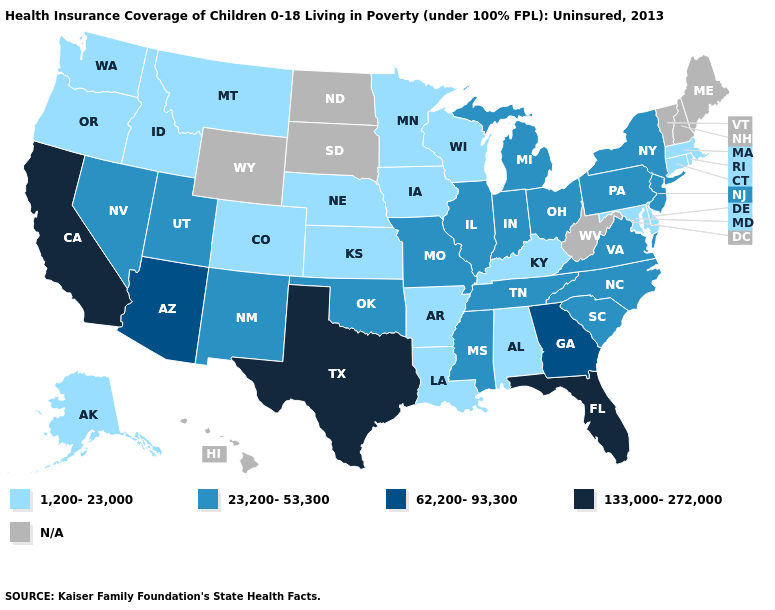How many symbols are there in the legend?
Quick response, please. 5. What is the value of Maryland?
Keep it brief. 1,200-23,000. What is the value of Georgia?
Quick response, please. 62,200-93,300. What is the value of South Dakota?
Keep it brief. N/A. Name the states that have a value in the range 1,200-23,000?
Write a very short answer. Alabama, Alaska, Arkansas, Colorado, Connecticut, Delaware, Idaho, Iowa, Kansas, Kentucky, Louisiana, Maryland, Massachusetts, Minnesota, Montana, Nebraska, Oregon, Rhode Island, Washington, Wisconsin. Name the states that have a value in the range 23,200-53,300?
Be succinct. Illinois, Indiana, Michigan, Mississippi, Missouri, Nevada, New Jersey, New Mexico, New York, North Carolina, Ohio, Oklahoma, Pennsylvania, South Carolina, Tennessee, Utah, Virginia. Among the states that border Virginia , does Maryland have the highest value?
Concise answer only. No. What is the lowest value in the USA?
Short answer required. 1,200-23,000. What is the highest value in states that border Pennsylvania?
Give a very brief answer. 23,200-53,300. Does Illinois have the lowest value in the MidWest?
Quick response, please. No. What is the highest value in the USA?
Give a very brief answer. 133,000-272,000. Name the states that have a value in the range 62,200-93,300?
Quick response, please. Arizona, Georgia. Does Texas have the highest value in the South?
Be succinct. Yes. Name the states that have a value in the range N/A?
Keep it brief. Hawaii, Maine, New Hampshire, North Dakota, South Dakota, Vermont, West Virginia, Wyoming. Does Michigan have the lowest value in the MidWest?
Write a very short answer. No. 